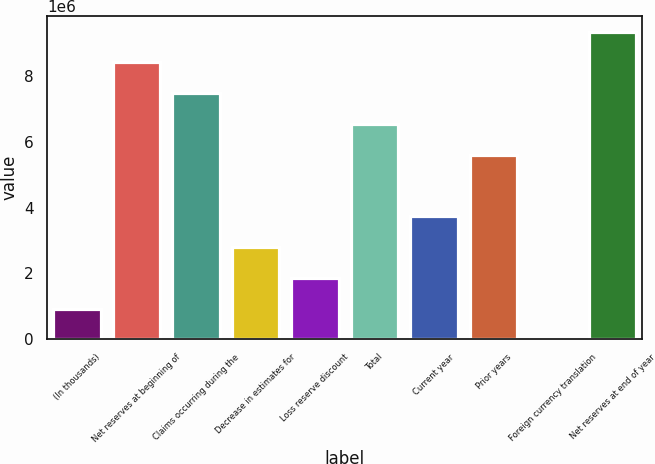Convert chart to OTSL. <chart><loc_0><loc_0><loc_500><loc_500><bar_chart><fcel>(In thousands)<fcel>Net reserves at beginning of<fcel>Claims occurring during the<fcel>Decrease in estimates for<fcel>Loss reserve discount<fcel>Total<fcel>Current year<fcel>Prior years<fcel>Foreign currency translation<fcel>Net reserves at end of year<nl><fcel>934815<fcel>8.40354e+06<fcel>7.46995e+06<fcel>2.802e+06<fcel>1.86841e+06<fcel>6.53636e+06<fcel>3.73559e+06<fcel>5.60277e+06<fcel>1224<fcel>9.33713e+06<nl></chart> 